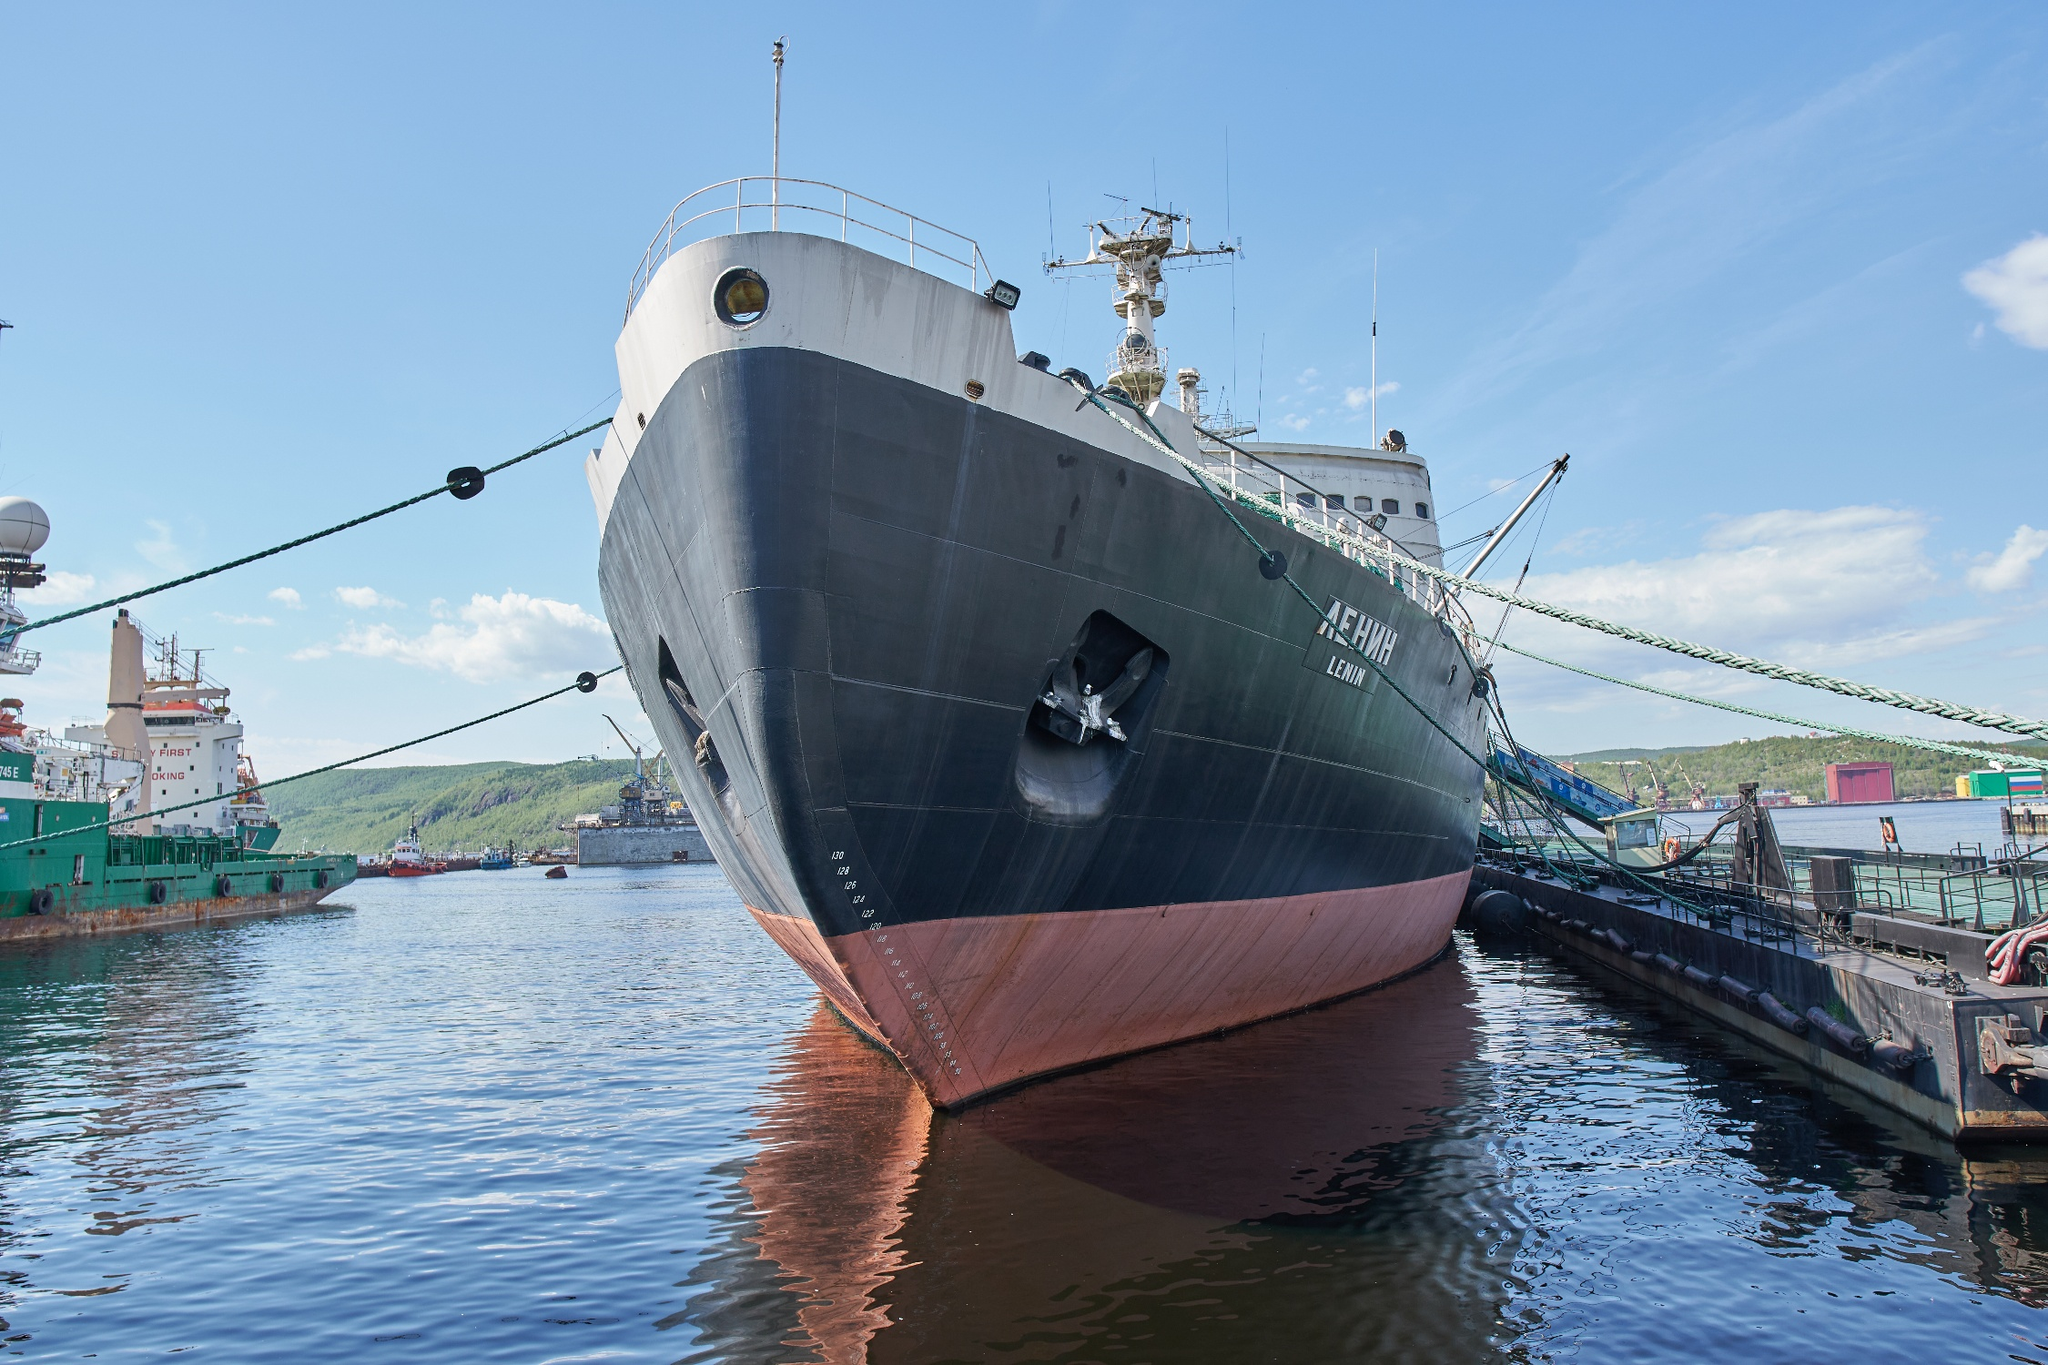What role does this ship play in modern maritime operations? In modern maritime operations, the Lenin primarily serves as a museum ship, preserving the history and technological achievements of its era. It no longer actively participates in icebreaking missions but continues to educate and inspire future generations about the advancements in nuclear-powered maritime technology and the importance of icebreakers in polar exploration and navigation. 